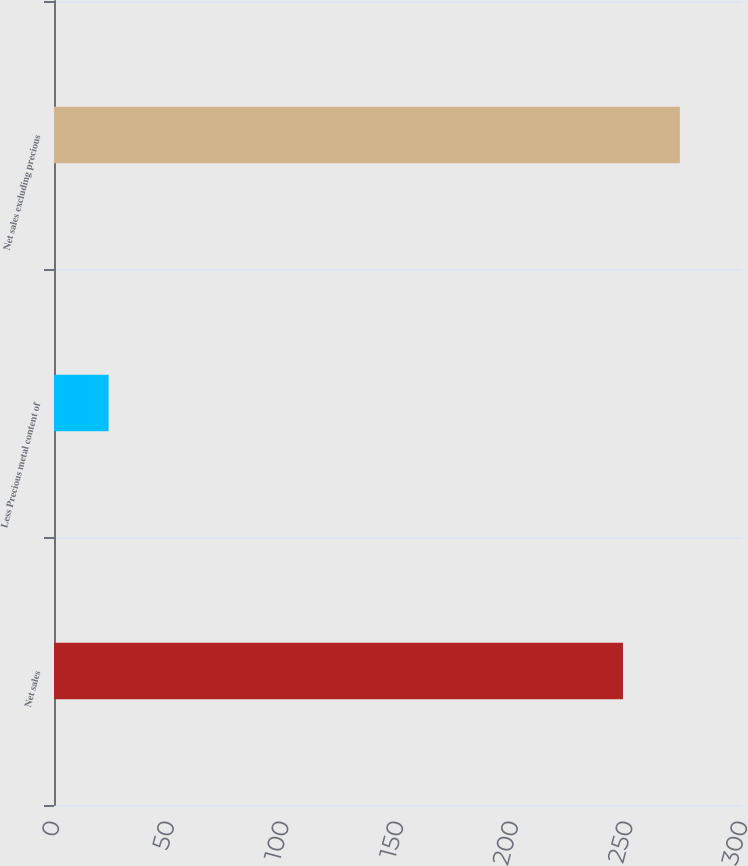Convert chart. <chart><loc_0><loc_0><loc_500><loc_500><bar_chart><fcel>Net sales<fcel>Less Precious metal content of<fcel>Net sales excluding precious<nl><fcel>248.1<fcel>23.8<fcel>272.91<nl></chart> 